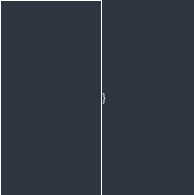Convert code to text. <code><loc_0><loc_0><loc_500><loc_500><_Kotlin_>
}
</code> 